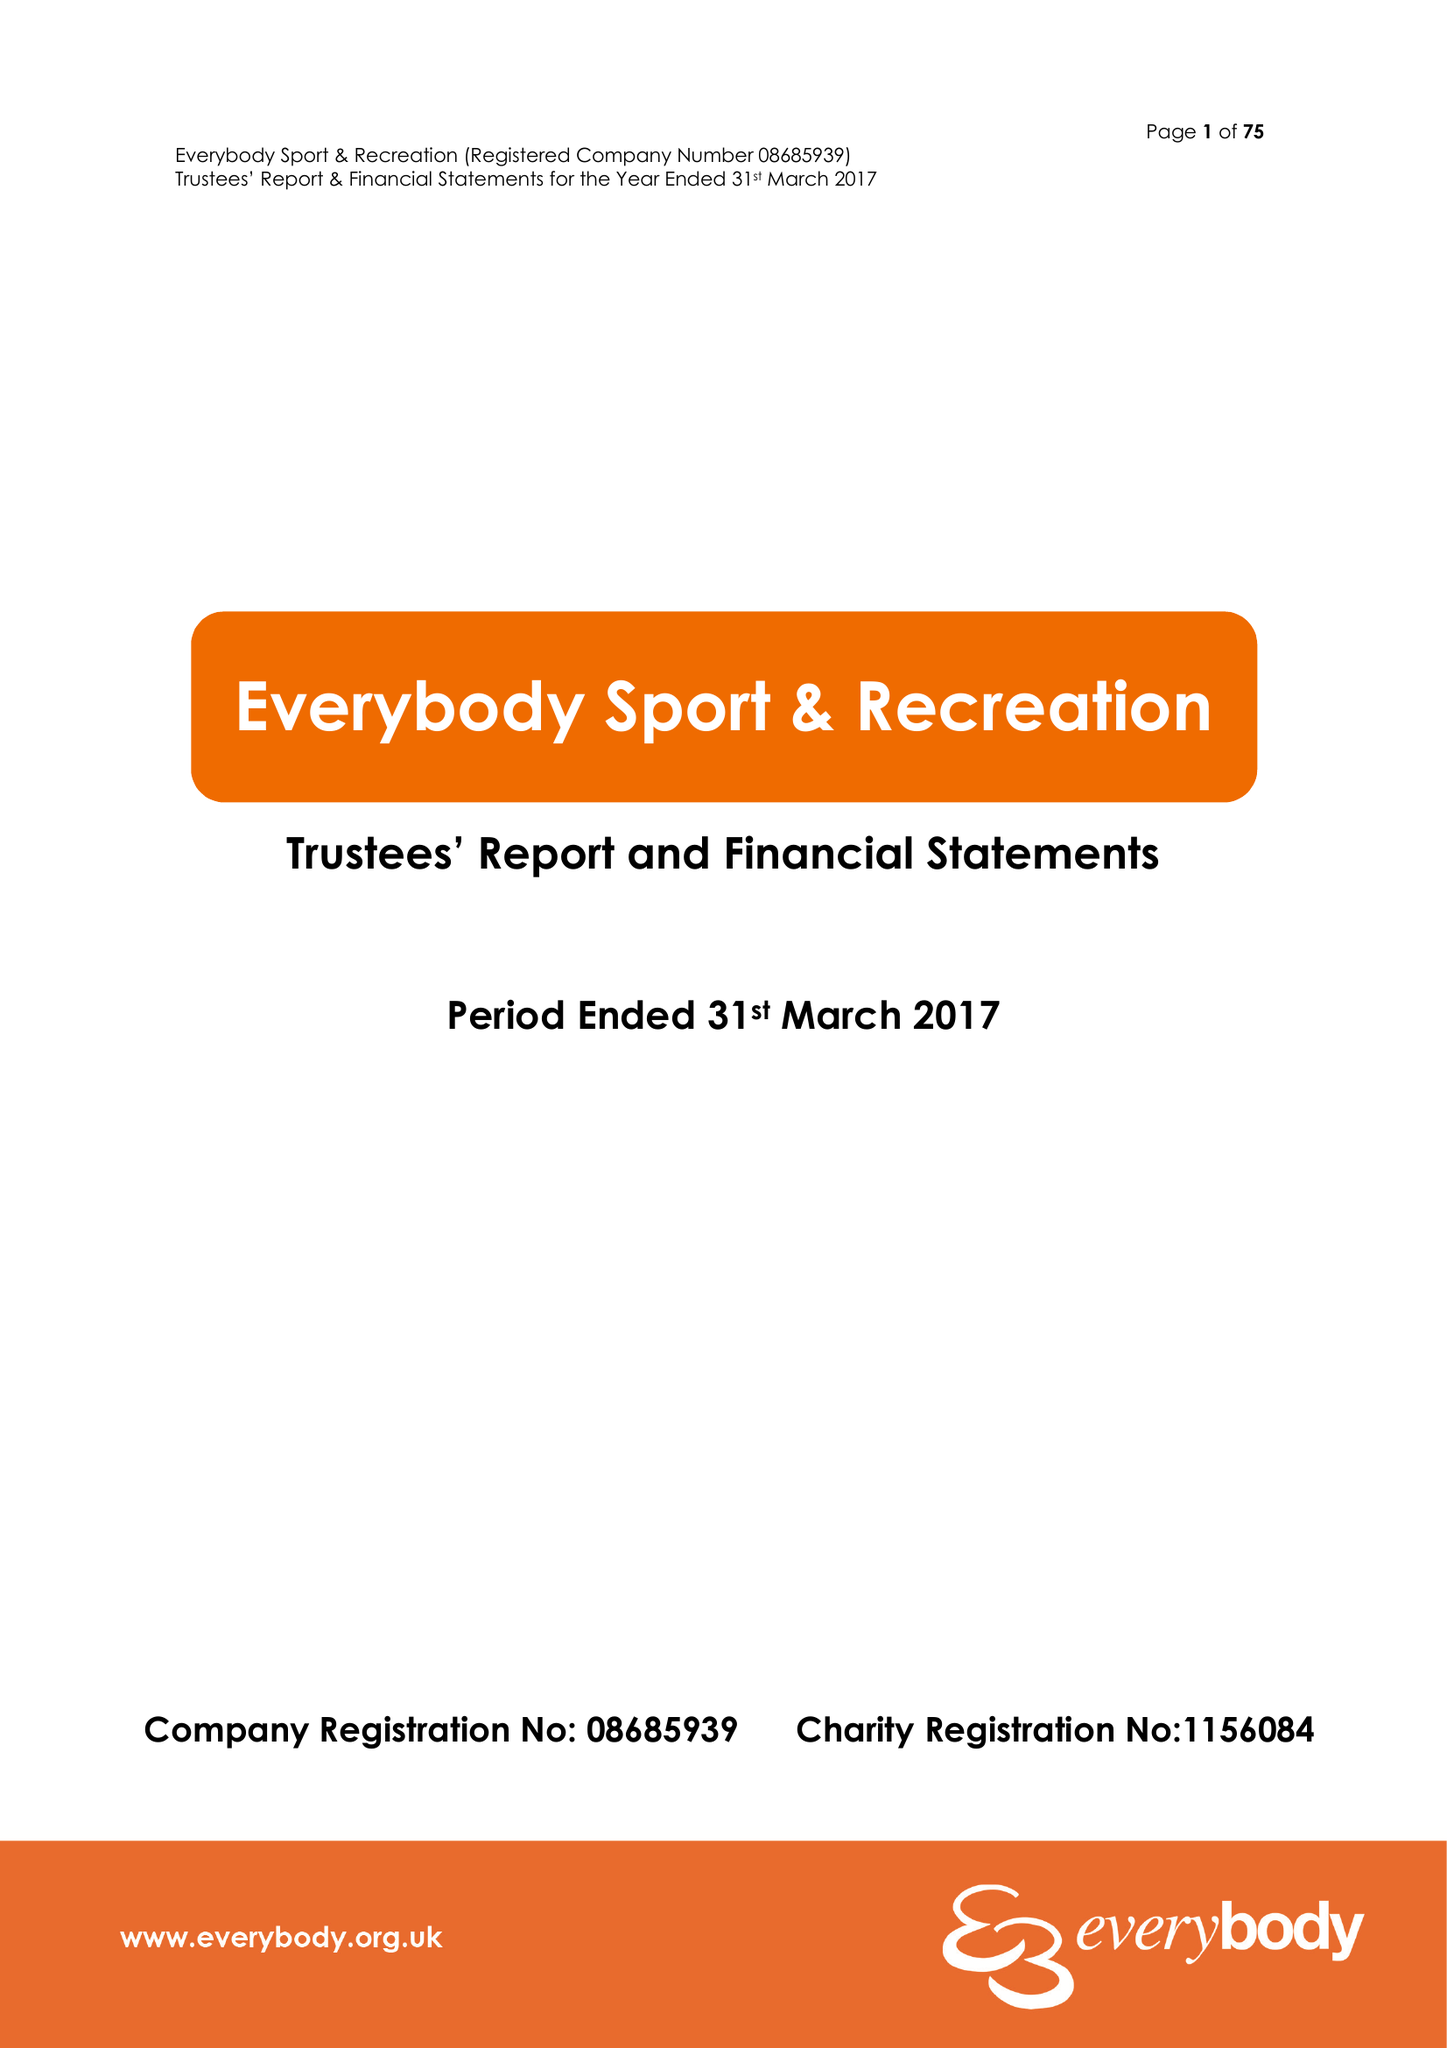What is the value for the spending_annually_in_british_pounds?
Answer the question using a single word or phrase. 15110750.00 